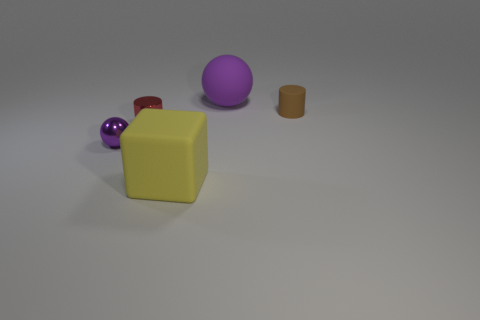There is a large object that is the same color as the metal sphere; what is it made of?
Your response must be concise. Rubber. There is a thing that is both to the right of the red shiny object and in front of the red cylinder; what color is it?
Your answer should be very brief. Yellow. There is another ball that is the same color as the small sphere; what size is it?
Offer a very short reply. Large. How many big things are either red things or yellow cubes?
Offer a terse response. 1. Is there any other thing of the same color as the cube?
Make the answer very short. No. The ball to the left of the large thing behind the tiny cylinder that is to the right of the large rubber ball is made of what material?
Your answer should be compact. Metal. What number of matte objects are small purple things or big things?
Ensure brevity in your answer.  2. What number of brown things are either metallic things or tiny cylinders?
Make the answer very short. 1. There is a thing in front of the small purple sphere; is it the same color as the big matte ball?
Provide a succinct answer. No. Do the brown thing and the tiny red object have the same material?
Keep it short and to the point. No. 